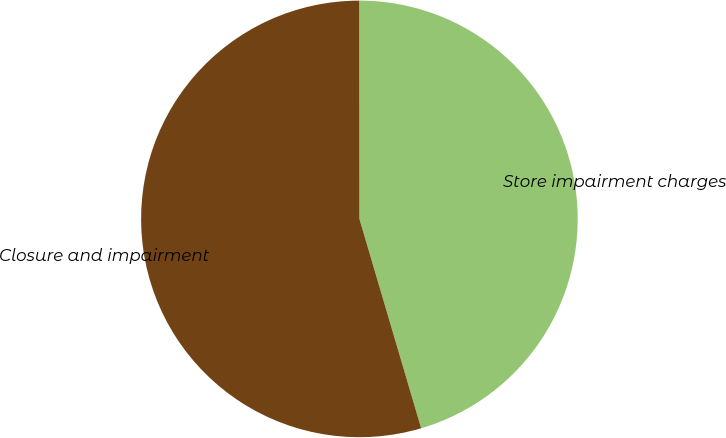<chart> <loc_0><loc_0><loc_500><loc_500><pie_chart><fcel>Store impairment charges<fcel>Closure and impairment<nl><fcel>45.45%<fcel>54.55%<nl></chart> 